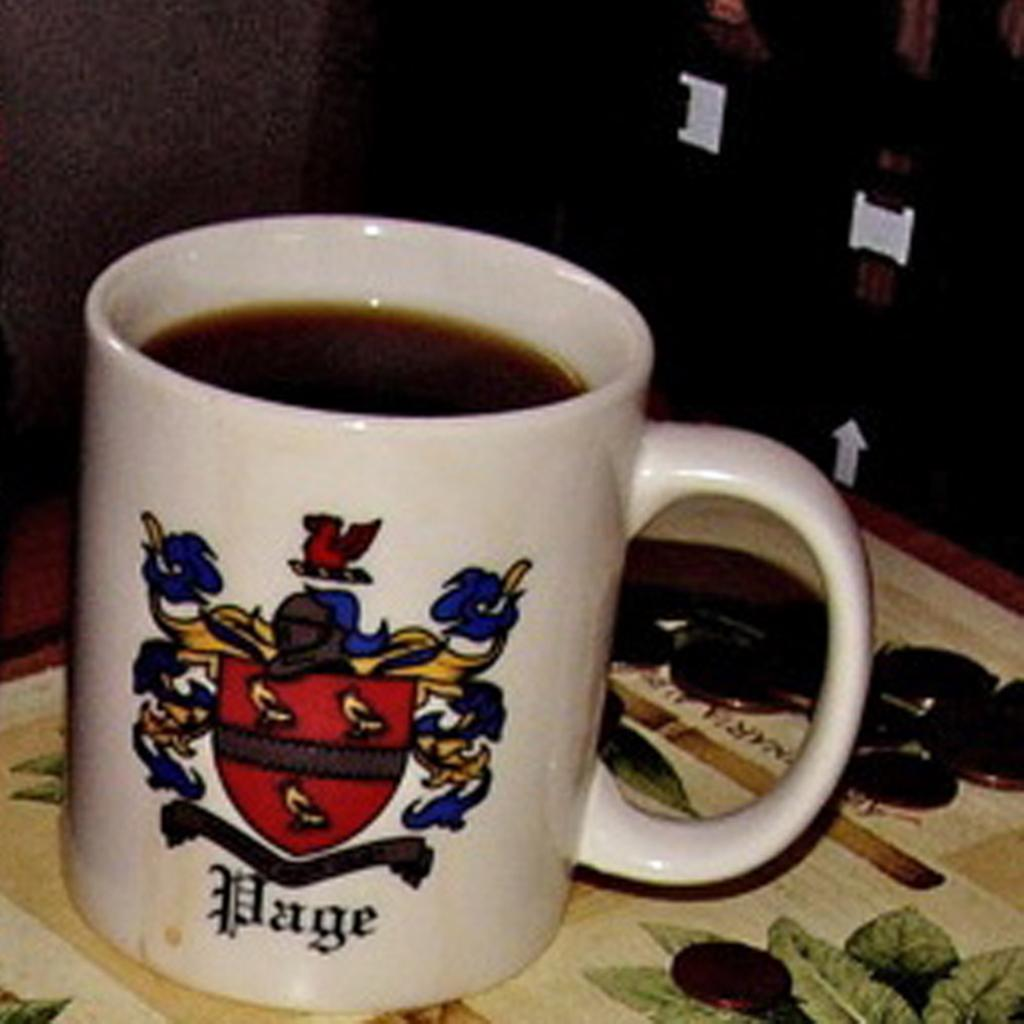<image>
Relay a brief, clear account of the picture shown. A white mug with the word Page on it is filled with coffee. 